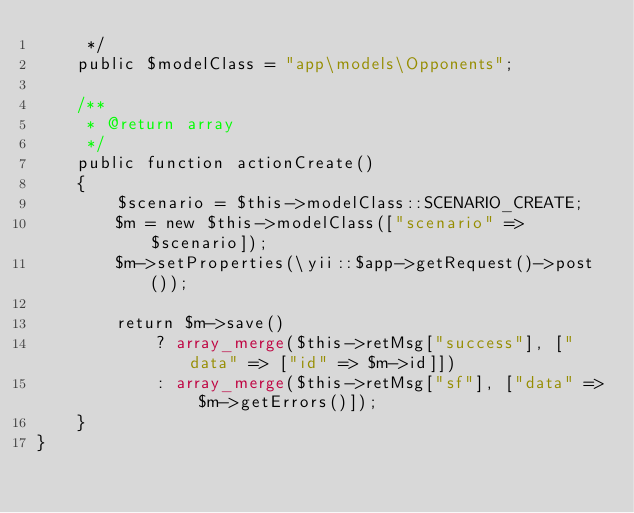<code> <loc_0><loc_0><loc_500><loc_500><_PHP_>     */
    public $modelClass = "app\models\Opponents";

    /**
     * @return array
     */
    public function actionCreate()
    {
        $scenario = $this->modelClass::SCENARIO_CREATE;
        $m = new $this->modelClass(["scenario" => $scenario]);
        $m->setProperties(\yii::$app->getRequest()->post());

        return $m->save()
            ? array_merge($this->retMsg["success"], ["data" => ["id" => $m->id]])
            : array_merge($this->retMsg["sf"], ["data" => $m->getErrors()]);
    }
}</code> 